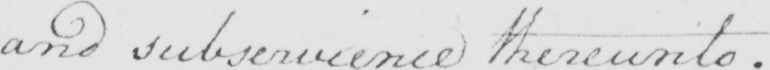What does this handwritten line say? and subservience thereunto . 